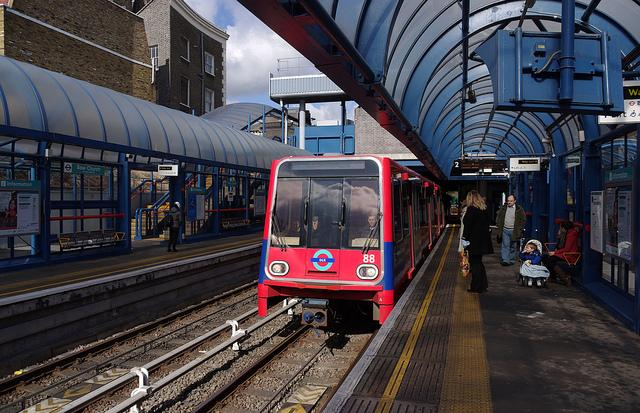Why are they all looking at the train? Please explain your reasoning. want ride. The people are looking at the train because the want to get on and ride it somewhere. 